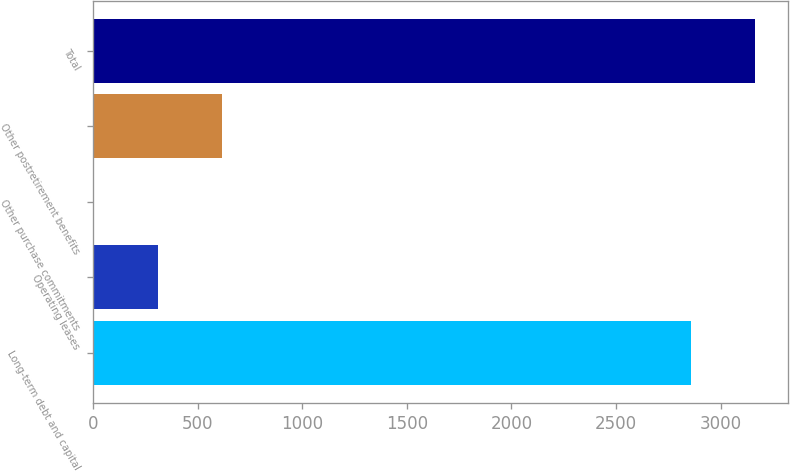Convert chart to OTSL. <chart><loc_0><loc_0><loc_500><loc_500><bar_chart><fcel>Long-term debt and capital<fcel>Operating leases<fcel>Other purchase commitments<fcel>Other postretirement benefits<fcel>Total<nl><fcel>2858<fcel>308.7<fcel>1<fcel>616.4<fcel>3165.7<nl></chart> 